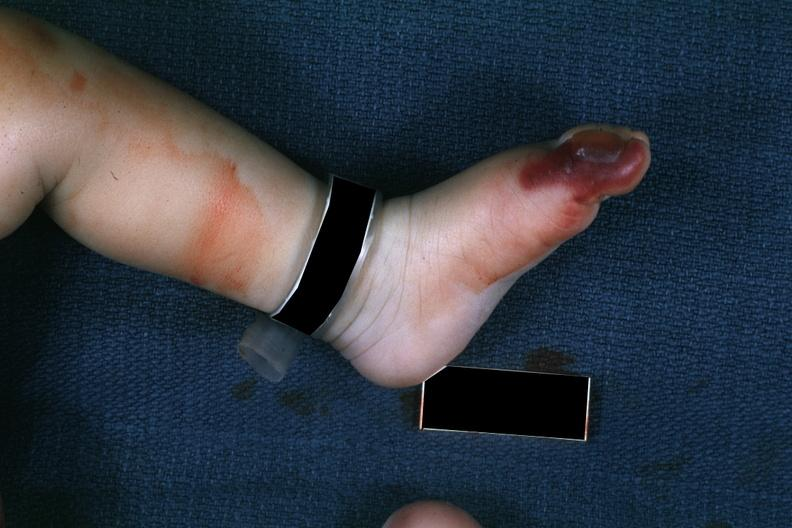does mesothelioma show 1 month old child with congenital aortic stenosis?
Answer the question using a single word or phrase. No 